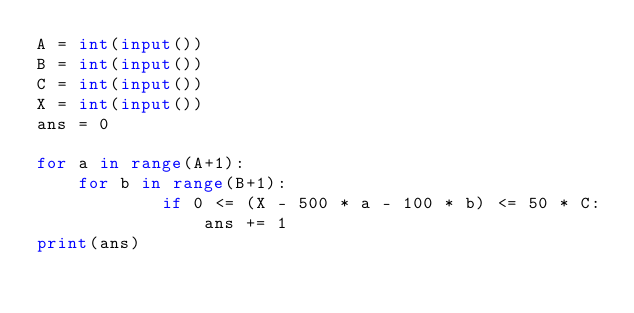Convert code to text. <code><loc_0><loc_0><loc_500><loc_500><_Python_>A = int(input())
B = int(input())
C = int(input())
X = int(input())
ans = 0

for a in range(A+1):
    for b in range(B+1):
            if 0 <= (X - 500 * a - 100 * b) <= 50 * C:
                ans += 1
print(ans)
</code> 